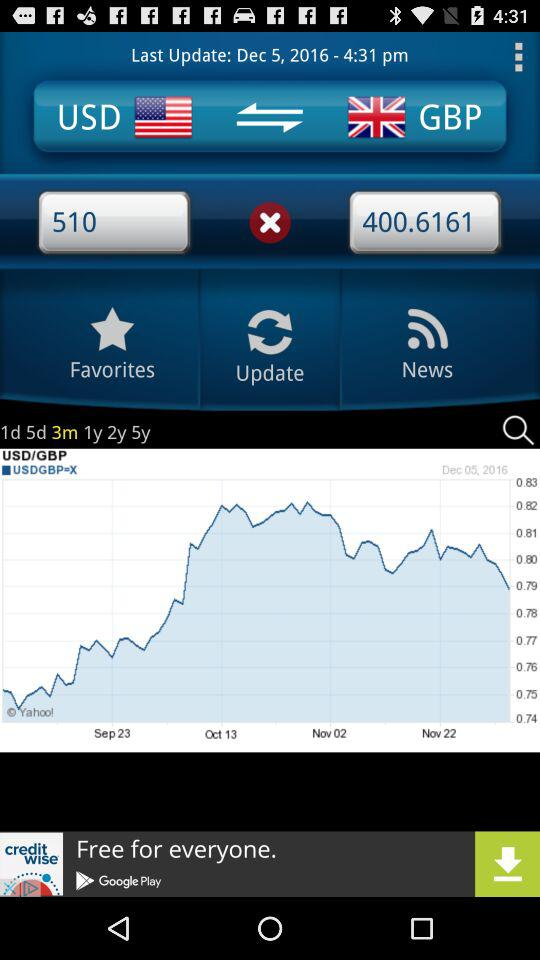When was it last updated? It was last updated on December 5, 2016 at 4:31 p.m. 